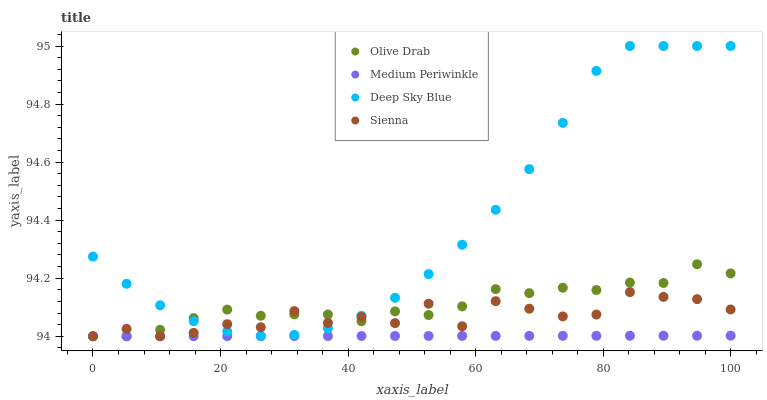Does Medium Periwinkle have the minimum area under the curve?
Answer yes or no. Yes. Does Deep Sky Blue have the maximum area under the curve?
Answer yes or no. Yes. Does Deep Sky Blue have the minimum area under the curve?
Answer yes or no. No. Does Medium Periwinkle have the maximum area under the curve?
Answer yes or no. No. Is Medium Periwinkle the smoothest?
Answer yes or no. Yes. Is Sienna the roughest?
Answer yes or no. Yes. Is Deep Sky Blue the smoothest?
Answer yes or no. No. Is Deep Sky Blue the roughest?
Answer yes or no. No. Does Sienna have the lowest value?
Answer yes or no. Yes. Does Deep Sky Blue have the lowest value?
Answer yes or no. No. Does Deep Sky Blue have the highest value?
Answer yes or no. Yes. Does Medium Periwinkle have the highest value?
Answer yes or no. No. Is Medium Periwinkle less than Deep Sky Blue?
Answer yes or no. Yes. Is Deep Sky Blue greater than Medium Periwinkle?
Answer yes or no. Yes. Does Olive Drab intersect Sienna?
Answer yes or no. Yes. Is Olive Drab less than Sienna?
Answer yes or no. No. Is Olive Drab greater than Sienna?
Answer yes or no. No. Does Medium Periwinkle intersect Deep Sky Blue?
Answer yes or no. No. 